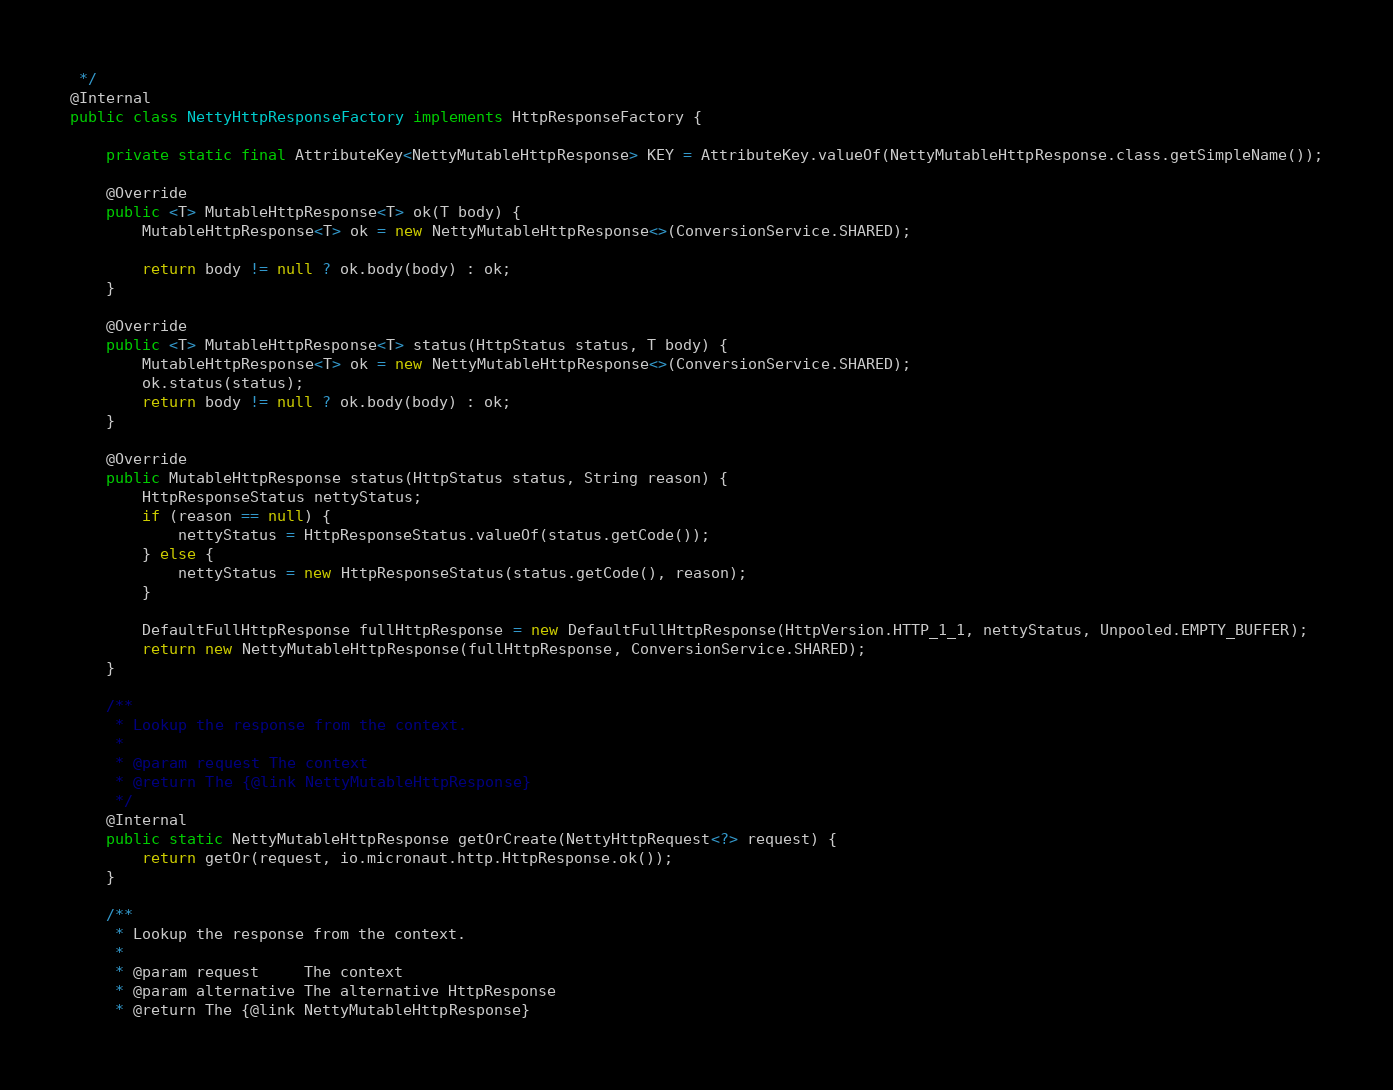Convert code to text. <code><loc_0><loc_0><loc_500><loc_500><_Java_> */
@Internal
public class NettyHttpResponseFactory implements HttpResponseFactory {

    private static final AttributeKey<NettyMutableHttpResponse> KEY = AttributeKey.valueOf(NettyMutableHttpResponse.class.getSimpleName());

    @Override
    public <T> MutableHttpResponse<T> ok(T body) {
        MutableHttpResponse<T> ok = new NettyMutableHttpResponse<>(ConversionService.SHARED);

        return body != null ? ok.body(body) : ok;
    }

    @Override
    public <T> MutableHttpResponse<T> status(HttpStatus status, T body) {
        MutableHttpResponse<T> ok = new NettyMutableHttpResponse<>(ConversionService.SHARED);
        ok.status(status);
        return body != null ? ok.body(body) : ok;
    }

    @Override
    public MutableHttpResponse status(HttpStatus status, String reason) {
        HttpResponseStatus nettyStatus;
        if (reason == null) {
            nettyStatus = HttpResponseStatus.valueOf(status.getCode());
        } else {
            nettyStatus = new HttpResponseStatus(status.getCode(), reason);
        }

        DefaultFullHttpResponse fullHttpResponse = new DefaultFullHttpResponse(HttpVersion.HTTP_1_1, nettyStatus, Unpooled.EMPTY_BUFFER);
        return new NettyMutableHttpResponse(fullHttpResponse, ConversionService.SHARED);
    }

    /**
     * Lookup the response from the context.
     *
     * @param request The context
     * @return The {@link NettyMutableHttpResponse}
     */
    @Internal
    public static NettyMutableHttpResponse getOrCreate(NettyHttpRequest<?> request) {
        return getOr(request, io.micronaut.http.HttpResponse.ok());
    }

    /**
     * Lookup the response from the context.
     *
     * @param request     The context
     * @param alternative The alternative HttpResponse
     * @return The {@link NettyMutableHttpResponse}</code> 